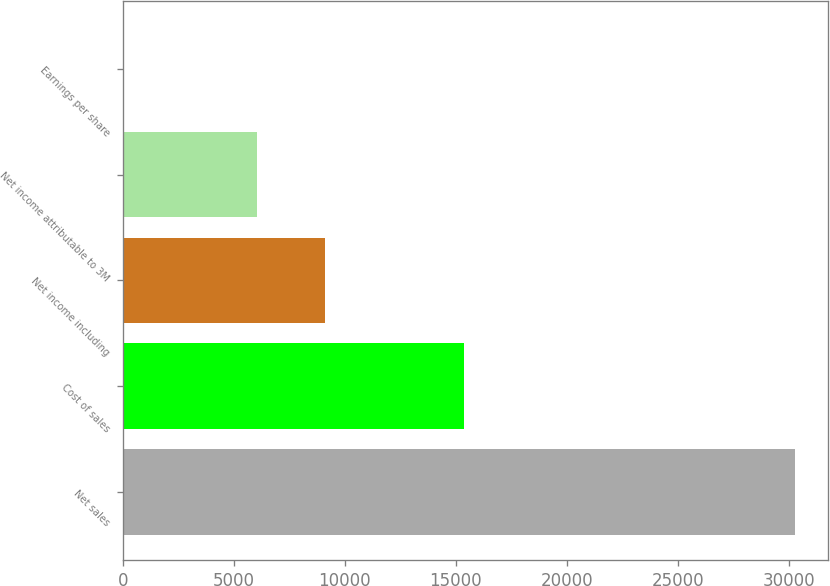<chart> <loc_0><loc_0><loc_500><loc_500><bar_chart><fcel>Net sales<fcel>Cost of sales<fcel>Net income including<fcel>Net income attributable to 3M<fcel>Earnings per share<nl><fcel>30274<fcel>15383<fcel>9087.5<fcel>6060.86<fcel>7.58<nl></chart> 